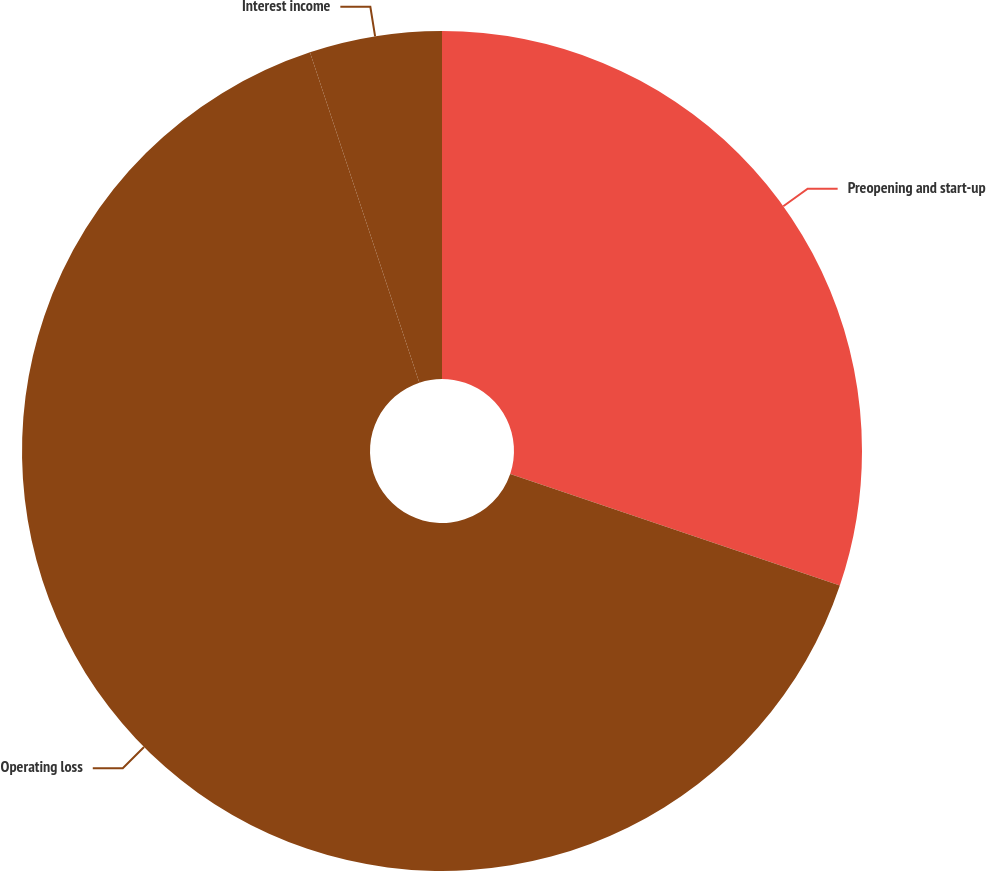Convert chart. <chart><loc_0><loc_0><loc_500><loc_500><pie_chart><fcel>Preopening and start-up<fcel>Operating loss<fcel>Interest income<nl><fcel>30.19%<fcel>64.71%<fcel>5.09%<nl></chart> 